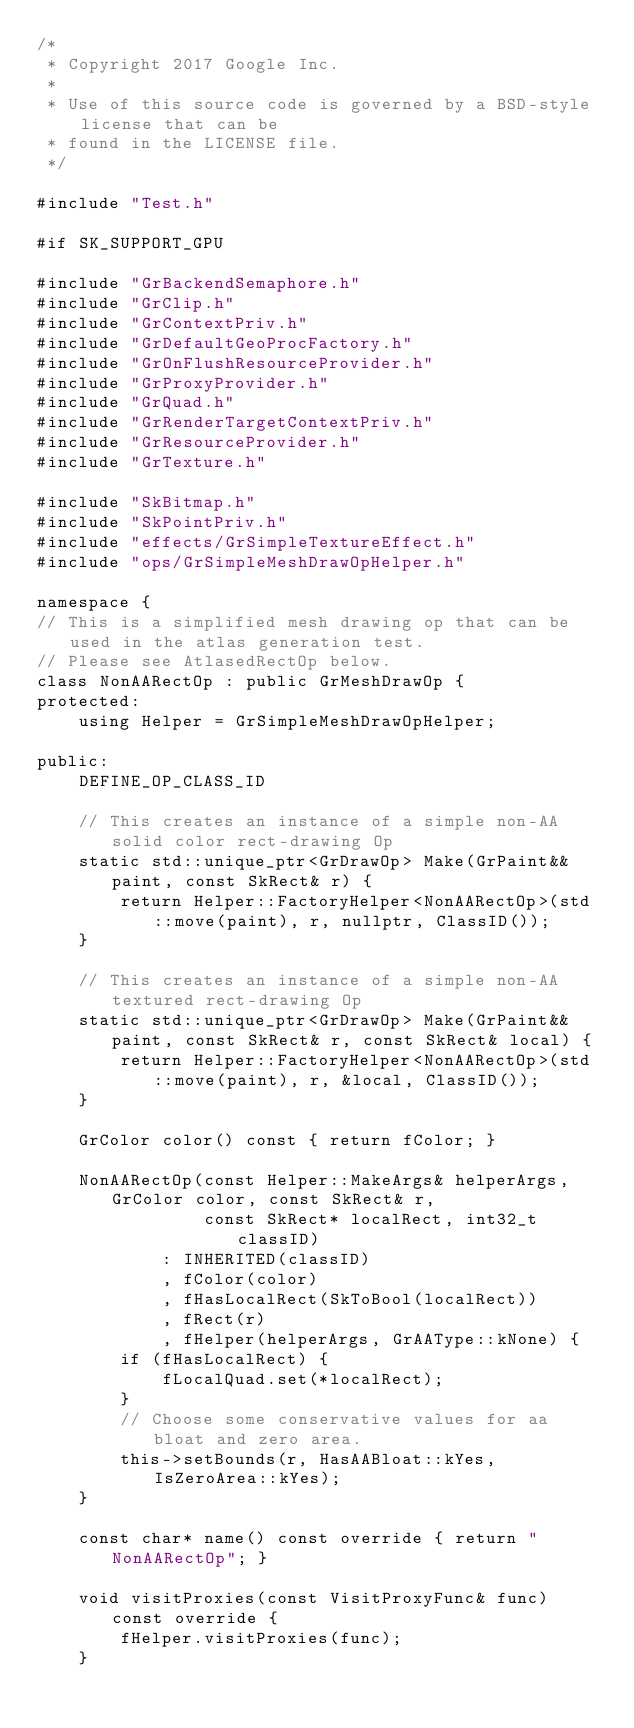Convert code to text. <code><loc_0><loc_0><loc_500><loc_500><_C++_>/*
 * Copyright 2017 Google Inc.
 *
 * Use of this source code is governed by a BSD-style license that can be
 * found in the LICENSE file.
 */

#include "Test.h"

#if SK_SUPPORT_GPU

#include "GrBackendSemaphore.h"
#include "GrClip.h"
#include "GrContextPriv.h"
#include "GrDefaultGeoProcFactory.h"
#include "GrOnFlushResourceProvider.h"
#include "GrProxyProvider.h"
#include "GrQuad.h"
#include "GrRenderTargetContextPriv.h"
#include "GrResourceProvider.h"
#include "GrTexture.h"

#include "SkBitmap.h"
#include "SkPointPriv.h"
#include "effects/GrSimpleTextureEffect.h"
#include "ops/GrSimpleMeshDrawOpHelper.h"

namespace {
// This is a simplified mesh drawing op that can be used in the atlas generation test.
// Please see AtlasedRectOp below.
class NonAARectOp : public GrMeshDrawOp {
protected:
    using Helper = GrSimpleMeshDrawOpHelper;

public:
    DEFINE_OP_CLASS_ID

    // This creates an instance of a simple non-AA solid color rect-drawing Op
    static std::unique_ptr<GrDrawOp> Make(GrPaint&& paint, const SkRect& r) {
        return Helper::FactoryHelper<NonAARectOp>(std::move(paint), r, nullptr, ClassID());
    }

    // This creates an instance of a simple non-AA textured rect-drawing Op
    static std::unique_ptr<GrDrawOp> Make(GrPaint&& paint, const SkRect& r, const SkRect& local) {
        return Helper::FactoryHelper<NonAARectOp>(std::move(paint), r, &local, ClassID());
    }

    GrColor color() const { return fColor; }

    NonAARectOp(const Helper::MakeArgs& helperArgs, GrColor color, const SkRect& r,
                const SkRect* localRect, int32_t classID)
            : INHERITED(classID)
            , fColor(color)
            , fHasLocalRect(SkToBool(localRect))
            , fRect(r)
            , fHelper(helperArgs, GrAAType::kNone) {
        if (fHasLocalRect) {
            fLocalQuad.set(*localRect);
        }
        // Choose some conservative values for aa bloat and zero area.
        this->setBounds(r, HasAABloat::kYes, IsZeroArea::kYes);
    }

    const char* name() const override { return "NonAARectOp"; }

    void visitProxies(const VisitProxyFunc& func) const override {
        fHelper.visitProxies(func);
    }
</code> 